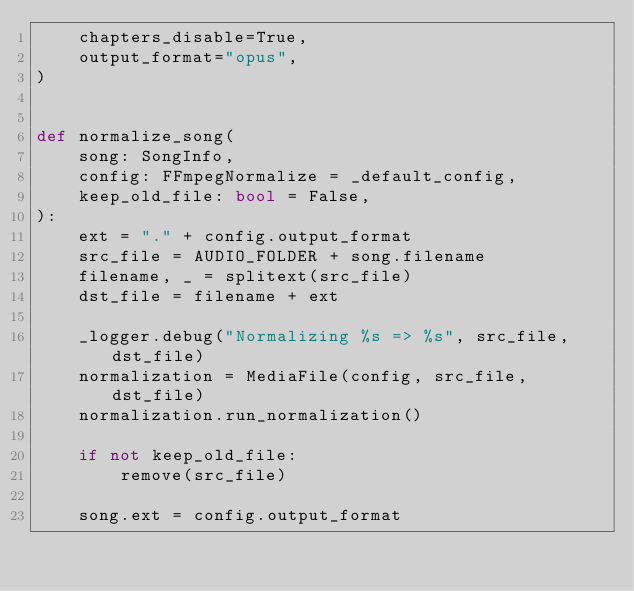<code> <loc_0><loc_0><loc_500><loc_500><_Python_>    chapters_disable=True,
    output_format="opus",
)


def normalize_song(
    song: SongInfo,
    config: FFmpegNormalize = _default_config,
    keep_old_file: bool = False,
):
    ext = "." + config.output_format
    src_file = AUDIO_FOLDER + song.filename
    filename, _ = splitext(src_file)
    dst_file = filename + ext

    _logger.debug("Normalizing %s => %s", src_file, dst_file)
    normalization = MediaFile(config, src_file, dst_file)
    normalization.run_normalization()

    if not keep_old_file:
        remove(src_file)

    song.ext = config.output_format
</code> 